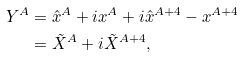Convert formula to latex. <formula><loc_0><loc_0><loc_500><loc_500>Y ^ { A } & = \hat { x } ^ { A } + i x ^ { A } + i \hat { x } ^ { A + 4 } - x ^ { A + 4 } \\ & = \tilde { X } ^ { A } + i \tilde { X } ^ { A + 4 } ,</formula> 